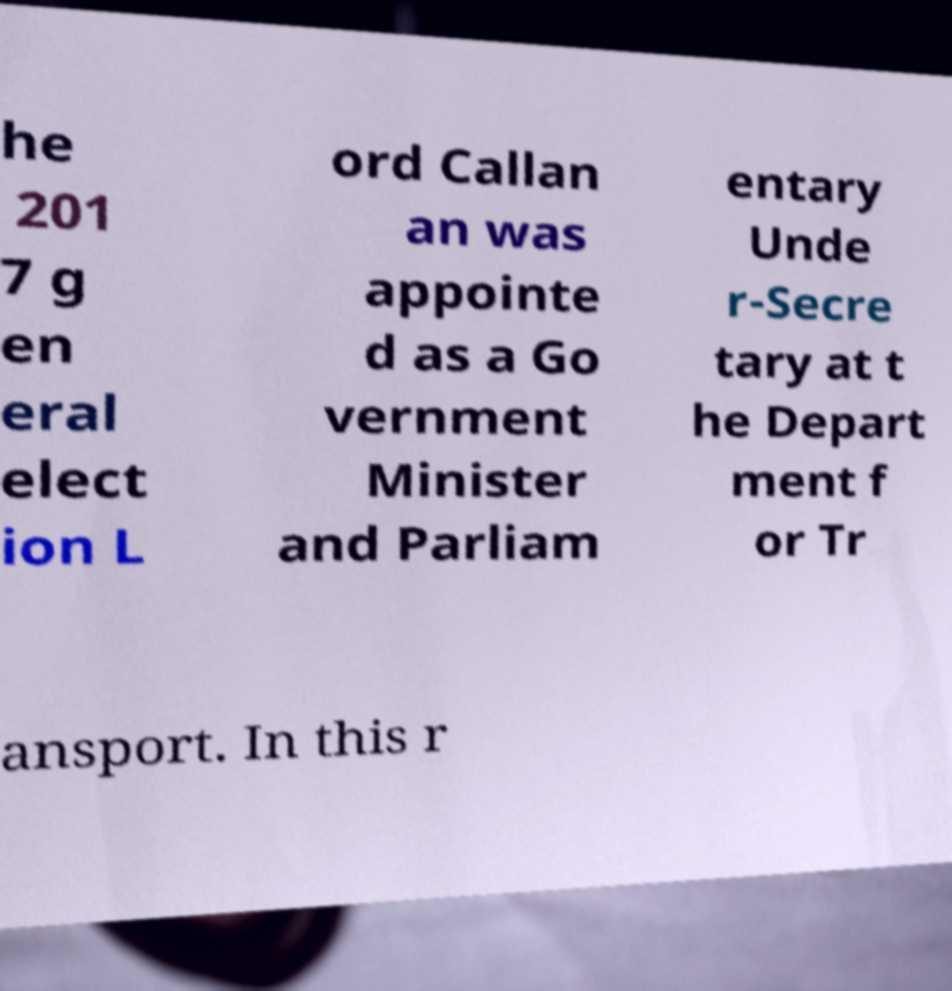Can you read and provide the text displayed in the image?This photo seems to have some interesting text. Can you extract and type it out for me? he 201 7 g en eral elect ion L ord Callan an was appointe d as a Go vernment Minister and Parliam entary Unde r-Secre tary at t he Depart ment f or Tr ansport. In this r 